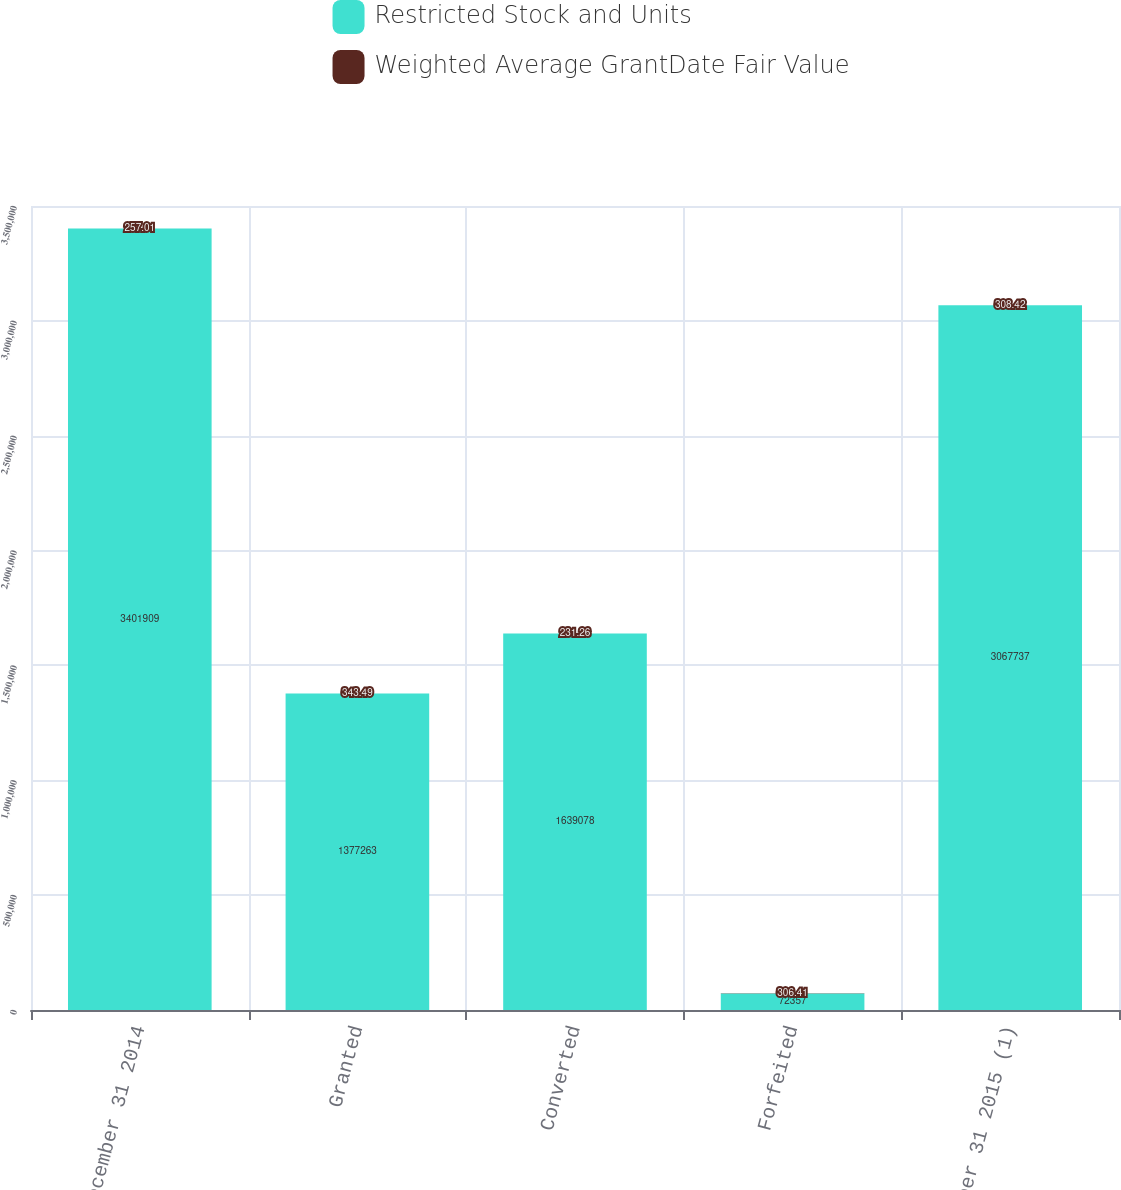Convert chart. <chart><loc_0><loc_0><loc_500><loc_500><stacked_bar_chart><ecel><fcel>December 31 2014<fcel>Granted<fcel>Converted<fcel>Forfeited<fcel>December 31 2015 (1)<nl><fcel>Restricted Stock and Units<fcel>3.40191e+06<fcel>1.37726e+06<fcel>1.63908e+06<fcel>72357<fcel>3.06774e+06<nl><fcel>Weighted Average GrantDate Fair Value<fcel>257.01<fcel>343.49<fcel>231.26<fcel>306.41<fcel>308.42<nl></chart> 